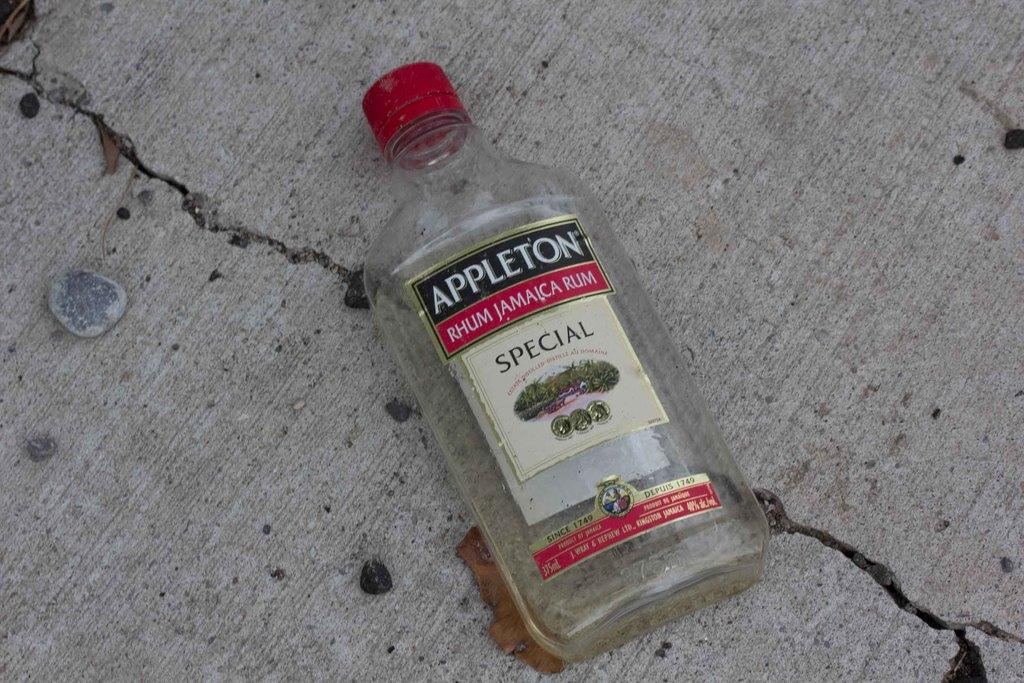What object can be seen in the image with a label? There is a bottle in the image with a label. What is written on the label of the bottle? The label on the bottle reads "Apple Tone". What type of straw is used to stir the liquid in the bottle? There is no straw visible in the image, and the bottle is not shown to contain any liquid. 